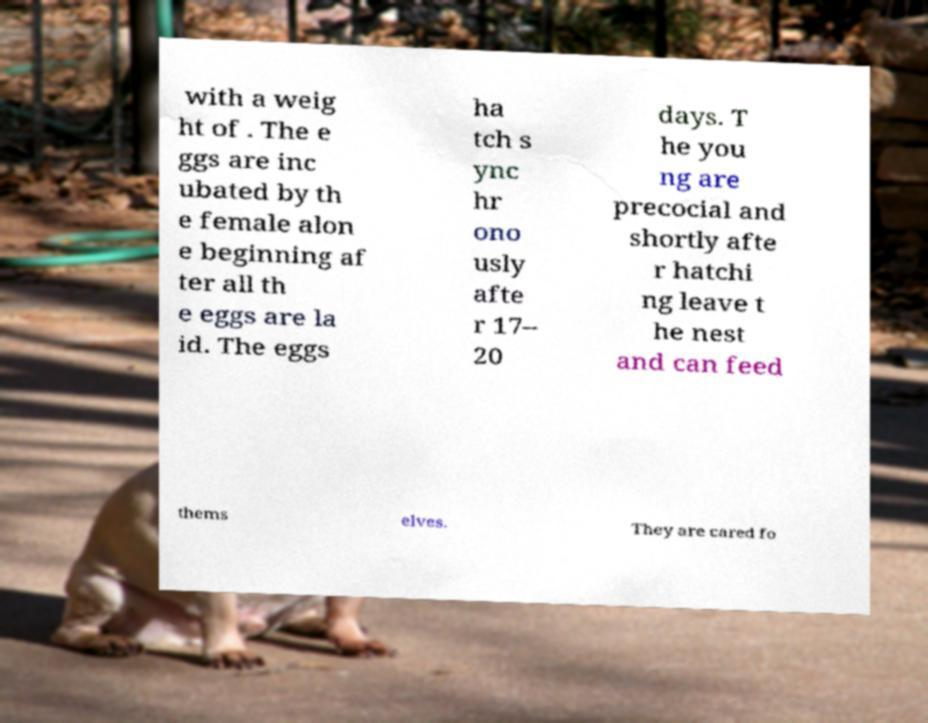There's text embedded in this image that I need extracted. Can you transcribe it verbatim? with a weig ht of . The e ggs are inc ubated by th e female alon e beginning af ter all th e eggs are la id. The eggs ha tch s ync hr ono usly afte r 17– 20 days. T he you ng are precocial and shortly afte r hatchi ng leave t he nest and can feed thems elves. They are cared fo 